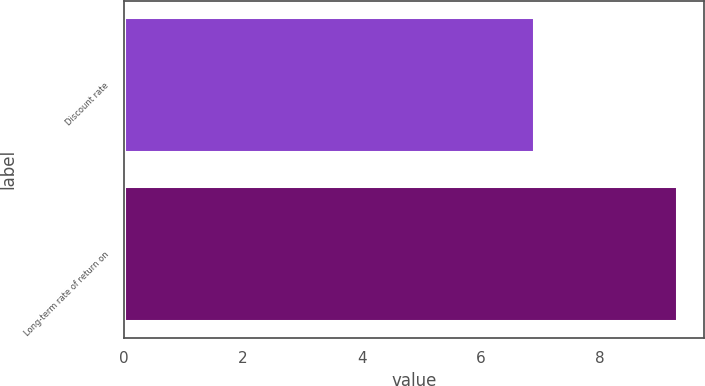Convert chart. <chart><loc_0><loc_0><loc_500><loc_500><bar_chart><fcel>Discount rate<fcel>Long-term rate of return on<nl><fcel>6.9<fcel>9.3<nl></chart> 